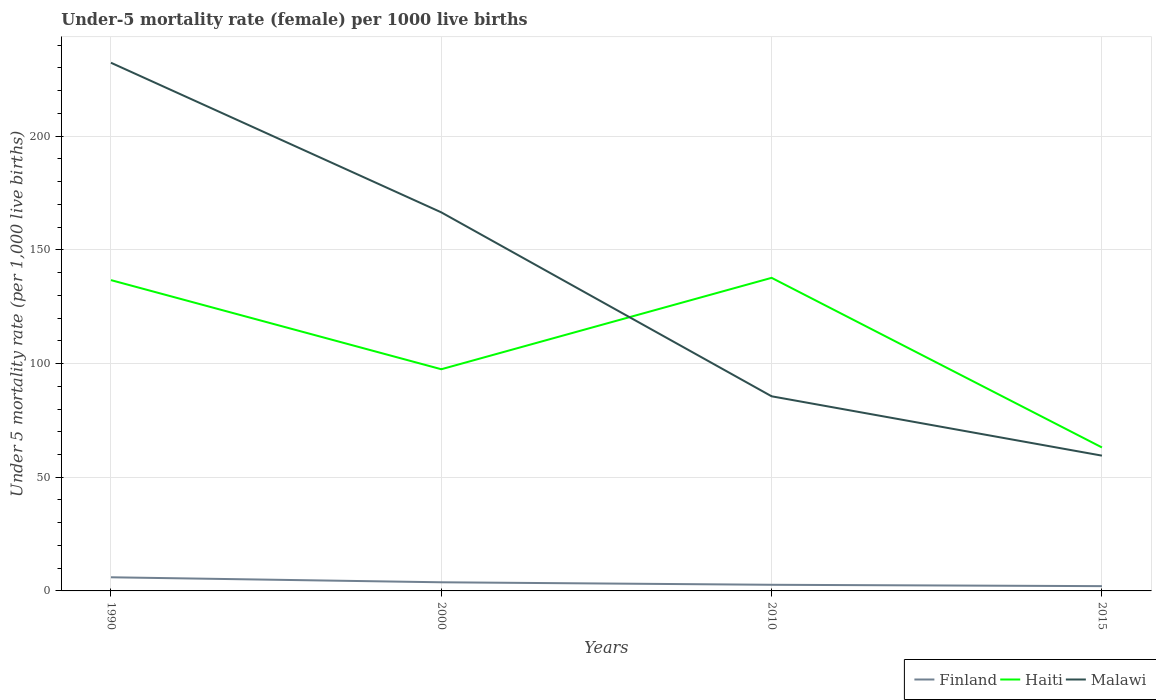Is the number of lines equal to the number of legend labels?
Provide a succinct answer. Yes. Across all years, what is the maximum under-five mortality rate in Finland?
Your answer should be compact. 2.1. In which year was the under-five mortality rate in Finland maximum?
Offer a very short reply. 2015. What is the total under-five mortality rate in Haiti in the graph?
Your answer should be compact. 39.2. What is the difference between the highest and the second highest under-five mortality rate in Finland?
Your answer should be very brief. 3.9. What is the difference between the highest and the lowest under-five mortality rate in Haiti?
Provide a short and direct response. 2. What is the difference between two consecutive major ticks on the Y-axis?
Ensure brevity in your answer.  50. Does the graph contain any zero values?
Keep it short and to the point. No. Where does the legend appear in the graph?
Make the answer very short. Bottom right. How many legend labels are there?
Keep it short and to the point. 3. What is the title of the graph?
Make the answer very short. Under-5 mortality rate (female) per 1000 live births. What is the label or title of the X-axis?
Offer a very short reply. Years. What is the label or title of the Y-axis?
Offer a terse response. Under 5 mortality rate (per 1,0 live births). What is the Under 5 mortality rate (per 1,000 live births) in Finland in 1990?
Your answer should be very brief. 6. What is the Under 5 mortality rate (per 1,000 live births) of Haiti in 1990?
Offer a very short reply. 136.7. What is the Under 5 mortality rate (per 1,000 live births) in Malawi in 1990?
Your answer should be compact. 232.3. What is the Under 5 mortality rate (per 1,000 live births) of Haiti in 2000?
Ensure brevity in your answer.  97.5. What is the Under 5 mortality rate (per 1,000 live births) of Malawi in 2000?
Your answer should be compact. 166.5. What is the Under 5 mortality rate (per 1,000 live births) of Haiti in 2010?
Keep it short and to the point. 137.7. What is the Under 5 mortality rate (per 1,000 live births) in Malawi in 2010?
Offer a very short reply. 85.6. What is the Under 5 mortality rate (per 1,000 live births) in Haiti in 2015?
Ensure brevity in your answer.  63.1. What is the Under 5 mortality rate (per 1,000 live births) in Malawi in 2015?
Provide a succinct answer. 59.5. Across all years, what is the maximum Under 5 mortality rate (per 1,000 live births) in Finland?
Make the answer very short. 6. Across all years, what is the maximum Under 5 mortality rate (per 1,000 live births) in Haiti?
Provide a succinct answer. 137.7. Across all years, what is the maximum Under 5 mortality rate (per 1,000 live births) of Malawi?
Provide a short and direct response. 232.3. Across all years, what is the minimum Under 5 mortality rate (per 1,000 live births) of Haiti?
Your answer should be very brief. 63.1. Across all years, what is the minimum Under 5 mortality rate (per 1,000 live births) in Malawi?
Your answer should be very brief. 59.5. What is the total Under 5 mortality rate (per 1,000 live births) of Finland in the graph?
Ensure brevity in your answer.  14.6. What is the total Under 5 mortality rate (per 1,000 live births) in Haiti in the graph?
Keep it short and to the point. 435. What is the total Under 5 mortality rate (per 1,000 live births) in Malawi in the graph?
Offer a very short reply. 543.9. What is the difference between the Under 5 mortality rate (per 1,000 live births) in Haiti in 1990 and that in 2000?
Provide a short and direct response. 39.2. What is the difference between the Under 5 mortality rate (per 1,000 live births) in Malawi in 1990 and that in 2000?
Ensure brevity in your answer.  65.8. What is the difference between the Under 5 mortality rate (per 1,000 live births) of Malawi in 1990 and that in 2010?
Your answer should be very brief. 146.7. What is the difference between the Under 5 mortality rate (per 1,000 live births) of Finland in 1990 and that in 2015?
Offer a very short reply. 3.9. What is the difference between the Under 5 mortality rate (per 1,000 live births) of Haiti in 1990 and that in 2015?
Make the answer very short. 73.6. What is the difference between the Under 5 mortality rate (per 1,000 live births) of Malawi in 1990 and that in 2015?
Keep it short and to the point. 172.8. What is the difference between the Under 5 mortality rate (per 1,000 live births) in Haiti in 2000 and that in 2010?
Offer a very short reply. -40.2. What is the difference between the Under 5 mortality rate (per 1,000 live births) of Malawi in 2000 and that in 2010?
Your response must be concise. 80.9. What is the difference between the Under 5 mortality rate (per 1,000 live births) of Finland in 2000 and that in 2015?
Ensure brevity in your answer.  1.7. What is the difference between the Under 5 mortality rate (per 1,000 live births) of Haiti in 2000 and that in 2015?
Keep it short and to the point. 34.4. What is the difference between the Under 5 mortality rate (per 1,000 live births) in Malawi in 2000 and that in 2015?
Offer a very short reply. 107. What is the difference between the Under 5 mortality rate (per 1,000 live births) in Finland in 2010 and that in 2015?
Your answer should be very brief. 0.6. What is the difference between the Under 5 mortality rate (per 1,000 live births) of Haiti in 2010 and that in 2015?
Offer a terse response. 74.6. What is the difference between the Under 5 mortality rate (per 1,000 live births) of Malawi in 2010 and that in 2015?
Keep it short and to the point. 26.1. What is the difference between the Under 5 mortality rate (per 1,000 live births) in Finland in 1990 and the Under 5 mortality rate (per 1,000 live births) in Haiti in 2000?
Provide a short and direct response. -91.5. What is the difference between the Under 5 mortality rate (per 1,000 live births) in Finland in 1990 and the Under 5 mortality rate (per 1,000 live births) in Malawi in 2000?
Provide a succinct answer. -160.5. What is the difference between the Under 5 mortality rate (per 1,000 live births) in Haiti in 1990 and the Under 5 mortality rate (per 1,000 live births) in Malawi in 2000?
Provide a short and direct response. -29.8. What is the difference between the Under 5 mortality rate (per 1,000 live births) in Finland in 1990 and the Under 5 mortality rate (per 1,000 live births) in Haiti in 2010?
Keep it short and to the point. -131.7. What is the difference between the Under 5 mortality rate (per 1,000 live births) in Finland in 1990 and the Under 5 mortality rate (per 1,000 live births) in Malawi in 2010?
Your response must be concise. -79.6. What is the difference between the Under 5 mortality rate (per 1,000 live births) of Haiti in 1990 and the Under 5 mortality rate (per 1,000 live births) of Malawi in 2010?
Provide a succinct answer. 51.1. What is the difference between the Under 5 mortality rate (per 1,000 live births) of Finland in 1990 and the Under 5 mortality rate (per 1,000 live births) of Haiti in 2015?
Your answer should be very brief. -57.1. What is the difference between the Under 5 mortality rate (per 1,000 live births) in Finland in 1990 and the Under 5 mortality rate (per 1,000 live births) in Malawi in 2015?
Ensure brevity in your answer.  -53.5. What is the difference between the Under 5 mortality rate (per 1,000 live births) in Haiti in 1990 and the Under 5 mortality rate (per 1,000 live births) in Malawi in 2015?
Keep it short and to the point. 77.2. What is the difference between the Under 5 mortality rate (per 1,000 live births) of Finland in 2000 and the Under 5 mortality rate (per 1,000 live births) of Haiti in 2010?
Offer a terse response. -133.9. What is the difference between the Under 5 mortality rate (per 1,000 live births) in Finland in 2000 and the Under 5 mortality rate (per 1,000 live births) in Malawi in 2010?
Your answer should be very brief. -81.8. What is the difference between the Under 5 mortality rate (per 1,000 live births) in Haiti in 2000 and the Under 5 mortality rate (per 1,000 live births) in Malawi in 2010?
Offer a terse response. 11.9. What is the difference between the Under 5 mortality rate (per 1,000 live births) in Finland in 2000 and the Under 5 mortality rate (per 1,000 live births) in Haiti in 2015?
Ensure brevity in your answer.  -59.3. What is the difference between the Under 5 mortality rate (per 1,000 live births) in Finland in 2000 and the Under 5 mortality rate (per 1,000 live births) in Malawi in 2015?
Offer a terse response. -55.7. What is the difference between the Under 5 mortality rate (per 1,000 live births) in Finland in 2010 and the Under 5 mortality rate (per 1,000 live births) in Haiti in 2015?
Offer a very short reply. -60.4. What is the difference between the Under 5 mortality rate (per 1,000 live births) of Finland in 2010 and the Under 5 mortality rate (per 1,000 live births) of Malawi in 2015?
Offer a very short reply. -56.8. What is the difference between the Under 5 mortality rate (per 1,000 live births) in Haiti in 2010 and the Under 5 mortality rate (per 1,000 live births) in Malawi in 2015?
Offer a terse response. 78.2. What is the average Under 5 mortality rate (per 1,000 live births) in Finland per year?
Provide a succinct answer. 3.65. What is the average Under 5 mortality rate (per 1,000 live births) of Haiti per year?
Offer a very short reply. 108.75. What is the average Under 5 mortality rate (per 1,000 live births) of Malawi per year?
Make the answer very short. 135.97. In the year 1990, what is the difference between the Under 5 mortality rate (per 1,000 live births) in Finland and Under 5 mortality rate (per 1,000 live births) in Haiti?
Give a very brief answer. -130.7. In the year 1990, what is the difference between the Under 5 mortality rate (per 1,000 live births) in Finland and Under 5 mortality rate (per 1,000 live births) in Malawi?
Make the answer very short. -226.3. In the year 1990, what is the difference between the Under 5 mortality rate (per 1,000 live births) of Haiti and Under 5 mortality rate (per 1,000 live births) of Malawi?
Your answer should be very brief. -95.6. In the year 2000, what is the difference between the Under 5 mortality rate (per 1,000 live births) of Finland and Under 5 mortality rate (per 1,000 live births) of Haiti?
Your response must be concise. -93.7. In the year 2000, what is the difference between the Under 5 mortality rate (per 1,000 live births) in Finland and Under 5 mortality rate (per 1,000 live births) in Malawi?
Your response must be concise. -162.7. In the year 2000, what is the difference between the Under 5 mortality rate (per 1,000 live births) in Haiti and Under 5 mortality rate (per 1,000 live births) in Malawi?
Your answer should be compact. -69. In the year 2010, what is the difference between the Under 5 mortality rate (per 1,000 live births) of Finland and Under 5 mortality rate (per 1,000 live births) of Haiti?
Provide a succinct answer. -135. In the year 2010, what is the difference between the Under 5 mortality rate (per 1,000 live births) of Finland and Under 5 mortality rate (per 1,000 live births) of Malawi?
Your answer should be compact. -82.9. In the year 2010, what is the difference between the Under 5 mortality rate (per 1,000 live births) in Haiti and Under 5 mortality rate (per 1,000 live births) in Malawi?
Keep it short and to the point. 52.1. In the year 2015, what is the difference between the Under 5 mortality rate (per 1,000 live births) of Finland and Under 5 mortality rate (per 1,000 live births) of Haiti?
Make the answer very short. -61. In the year 2015, what is the difference between the Under 5 mortality rate (per 1,000 live births) in Finland and Under 5 mortality rate (per 1,000 live births) in Malawi?
Your answer should be very brief. -57.4. What is the ratio of the Under 5 mortality rate (per 1,000 live births) in Finland in 1990 to that in 2000?
Your answer should be very brief. 1.58. What is the ratio of the Under 5 mortality rate (per 1,000 live births) in Haiti in 1990 to that in 2000?
Keep it short and to the point. 1.4. What is the ratio of the Under 5 mortality rate (per 1,000 live births) in Malawi in 1990 to that in 2000?
Keep it short and to the point. 1.4. What is the ratio of the Under 5 mortality rate (per 1,000 live births) in Finland in 1990 to that in 2010?
Your answer should be very brief. 2.22. What is the ratio of the Under 5 mortality rate (per 1,000 live births) of Haiti in 1990 to that in 2010?
Your response must be concise. 0.99. What is the ratio of the Under 5 mortality rate (per 1,000 live births) of Malawi in 1990 to that in 2010?
Your answer should be very brief. 2.71. What is the ratio of the Under 5 mortality rate (per 1,000 live births) of Finland in 1990 to that in 2015?
Offer a terse response. 2.86. What is the ratio of the Under 5 mortality rate (per 1,000 live births) in Haiti in 1990 to that in 2015?
Provide a succinct answer. 2.17. What is the ratio of the Under 5 mortality rate (per 1,000 live births) of Malawi in 1990 to that in 2015?
Ensure brevity in your answer.  3.9. What is the ratio of the Under 5 mortality rate (per 1,000 live births) of Finland in 2000 to that in 2010?
Your answer should be compact. 1.41. What is the ratio of the Under 5 mortality rate (per 1,000 live births) of Haiti in 2000 to that in 2010?
Your response must be concise. 0.71. What is the ratio of the Under 5 mortality rate (per 1,000 live births) of Malawi in 2000 to that in 2010?
Ensure brevity in your answer.  1.95. What is the ratio of the Under 5 mortality rate (per 1,000 live births) in Finland in 2000 to that in 2015?
Provide a succinct answer. 1.81. What is the ratio of the Under 5 mortality rate (per 1,000 live births) in Haiti in 2000 to that in 2015?
Your response must be concise. 1.55. What is the ratio of the Under 5 mortality rate (per 1,000 live births) of Malawi in 2000 to that in 2015?
Ensure brevity in your answer.  2.8. What is the ratio of the Under 5 mortality rate (per 1,000 live births) in Finland in 2010 to that in 2015?
Your response must be concise. 1.29. What is the ratio of the Under 5 mortality rate (per 1,000 live births) of Haiti in 2010 to that in 2015?
Provide a short and direct response. 2.18. What is the ratio of the Under 5 mortality rate (per 1,000 live births) of Malawi in 2010 to that in 2015?
Provide a succinct answer. 1.44. What is the difference between the highest and the second highest Under 5 mortality rate (per 1,000 live births) in Malawi?
Your response must be concise. 65.8. What is the difference between the highest and the lowest Under 5 mortality rate (per 1,000 live births) in Finland?
Offer a very short reply. 3.9. What is the difference between the highest and the lowest Under 5 mortality rate (per 1,000 live births) of Haiti?
Ensure brevity in your answer.  74.6. What is the difference between the highest and the lowest Under 5 mortality rate (per 1,000 live births) of Malawi?
Your answer should be very brief. 172.8. 